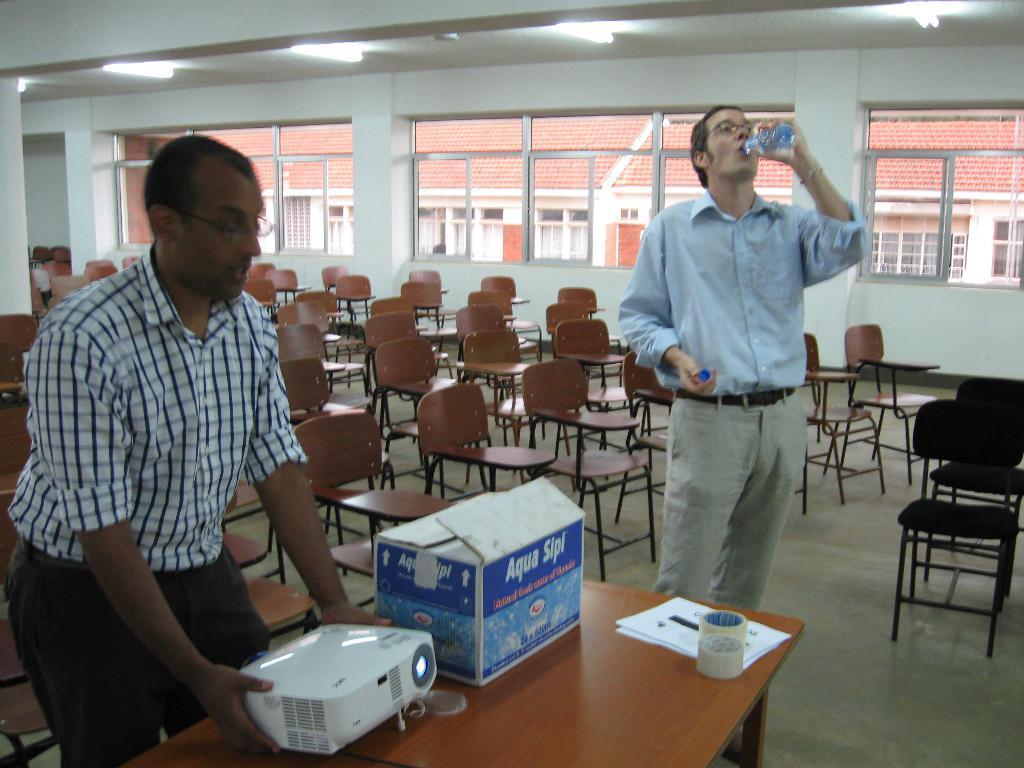Can you describe this image briefly? There is a Classroom which includes two persons, one table, many number of chairs. The person standing on the left side wearing spectacles is adjusting the Projector on the table and there is one box, some papers and two bundles of tape placed on the table and the person on the right side also wearing spectacles is drinking water and in the background there are some windows from which we can see the Building with the red rooftop. 